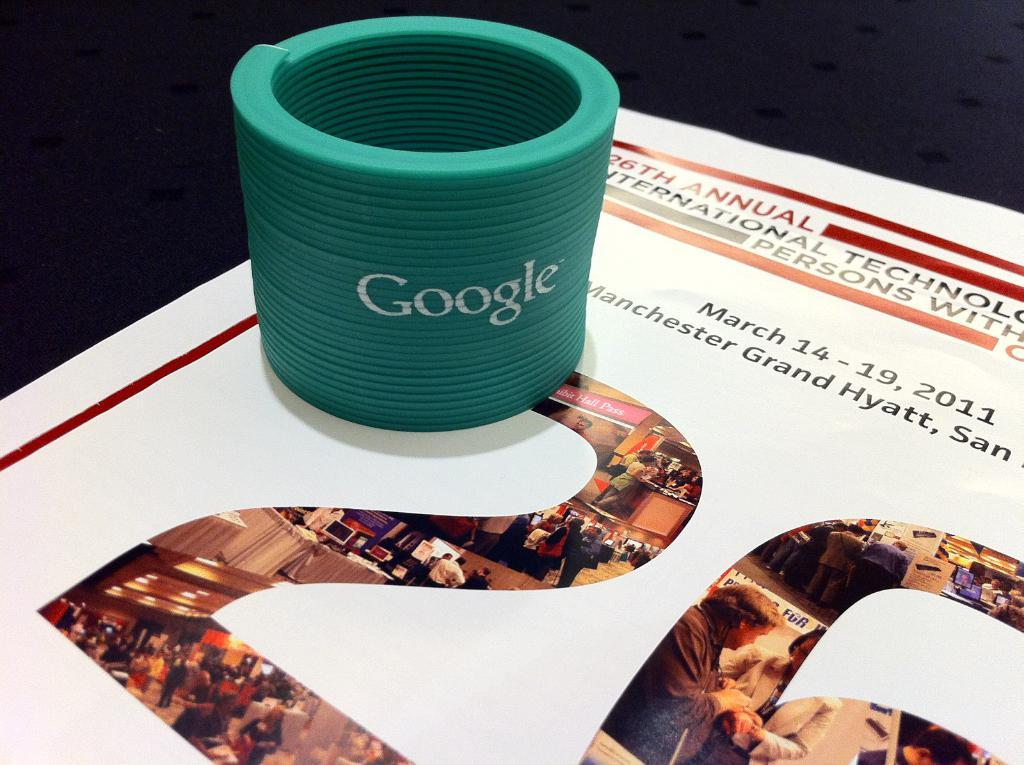What is on the paper in the image? The paper contains a depiction of a crowd, tables, cloth, and lights. What is holding the paper in the image? There is a holder on the paper. What type of lace can be seen on the tables in the image? There is no lace present on the tables in the image; the paper only contains a depiction of tables. How do the lights communicate with each other in the image? The lights do not communicate with each other in the image; they are depicted as stationary objects. 